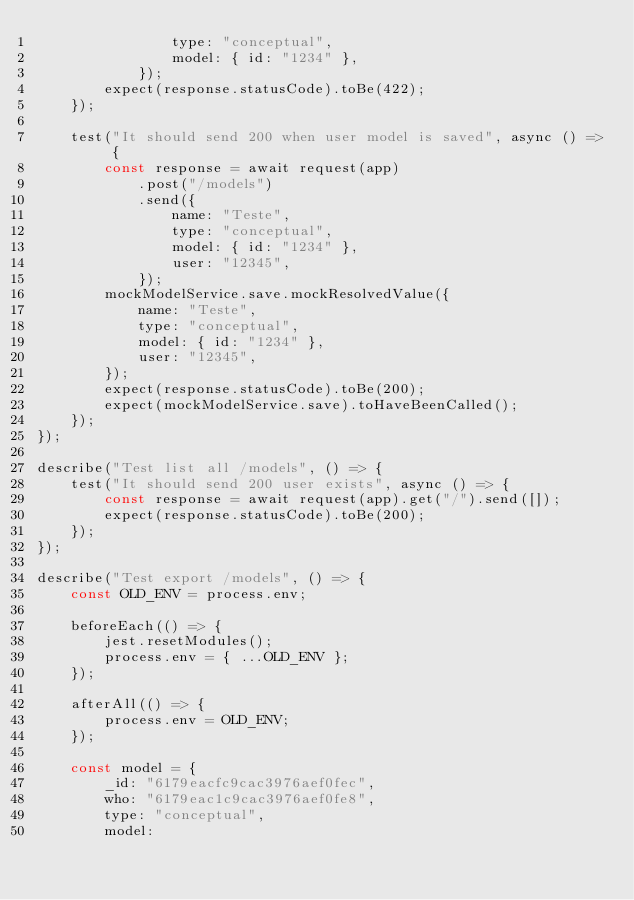<code> <loc_0><loc_0><loc_500><loc_500><_JavaScript_>				type: "conceptual",
				model: { id: "1234" },
			});
		expect(response.statusCode).toBe(422);
	});

	test("It should send 200 when user model is saved", async () => {
		const response = await request(app)
			.post("/models")
			.send({
				name: "Teste",
				type: "conceptual",
				model: { id: "1234" },
				user: "12345",
			});
		mockModelService.save.mockResolvedValue({
			name: "Teste",
			type: "conceptual",
			model: { id: "1234" },
			user: "12345",
		});
		expect(response.statusCode).toBe(200);
		expect(mockModelService.save).toHaveBeenCalled();
	});
});

describe("Test list all /models", () => {
	test("It should send 200 user exists", async () => {
		const response = await request(app).get("/").send([]);
		expect(response.statusCode).toBe(200);
	});
});

describe("Test export /models", () => {
	const OLD_ENV = process.env;

	beforeEach(() => {
		jest.resetModules();
		process.env = { ...OLD_ENV };
	});

	afterAll(() => {
		process.env = OLD_ENV;
	});

	const model = {
		_id: "6179eacfc9cac3976aef0fec",
		who: "6179eac1c9cac3976aef0fe8",
		type: "conceptual",
		model:</code> 